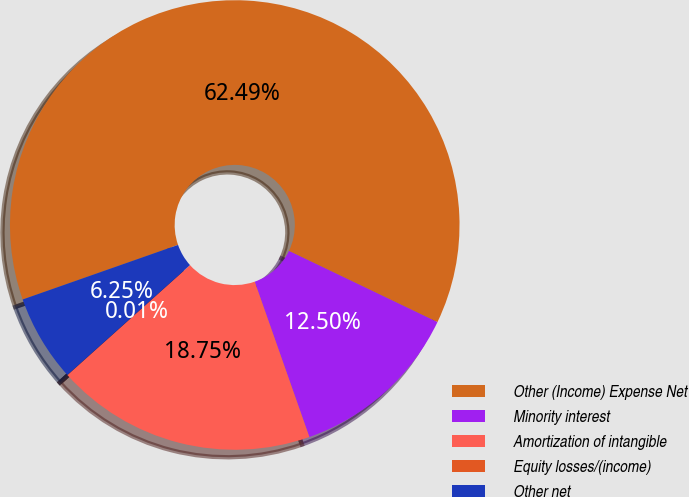<chart> <loc_0><loc_0><loc_500><loc_500><pie_chart><fcel>Other (Income) Expense Net<fcel>Minority interest<fcel>Amortization of intangible<fcel>Equity losses/(income)<fcel>Other net<nl><fcel>62.49%<fcel>12.5%<fcel>18.75%<fcel>0.01%<fcel>6.25%<nl></chart> 